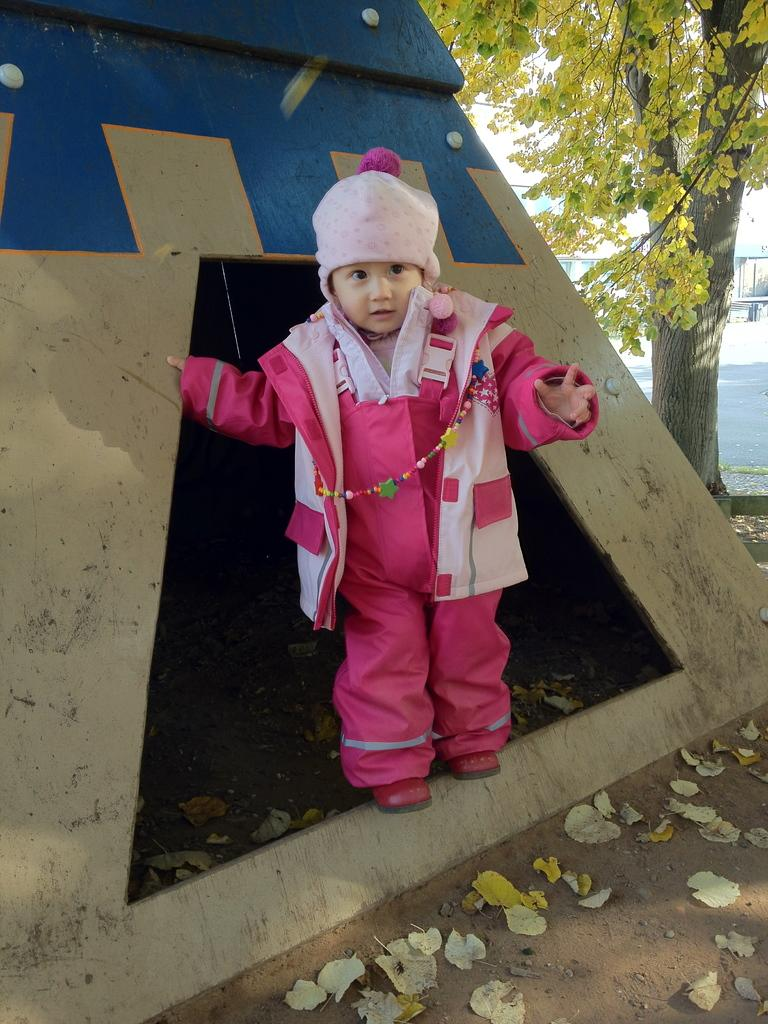What can be seen in the image? There is a child in the image. What is the child wearing on their head? The child is wearing a cap. What type of footwear is the child wearing? The child is wearing shoes. What is the child's posture in the image? The child is standing. What is present on the ground in the image? Dried leaves are present on the ground. What type of plant can be seen in the image? There is a tree in the image. What is visible in the background of the image? There is a road visible in the background. What type of crack can be seen in the child's shoes in the image? There is no crack visible in the child's shoes in the image. How many crows are sitting on the tree in the image? There are no crows present in the image; only a tree is visible. 